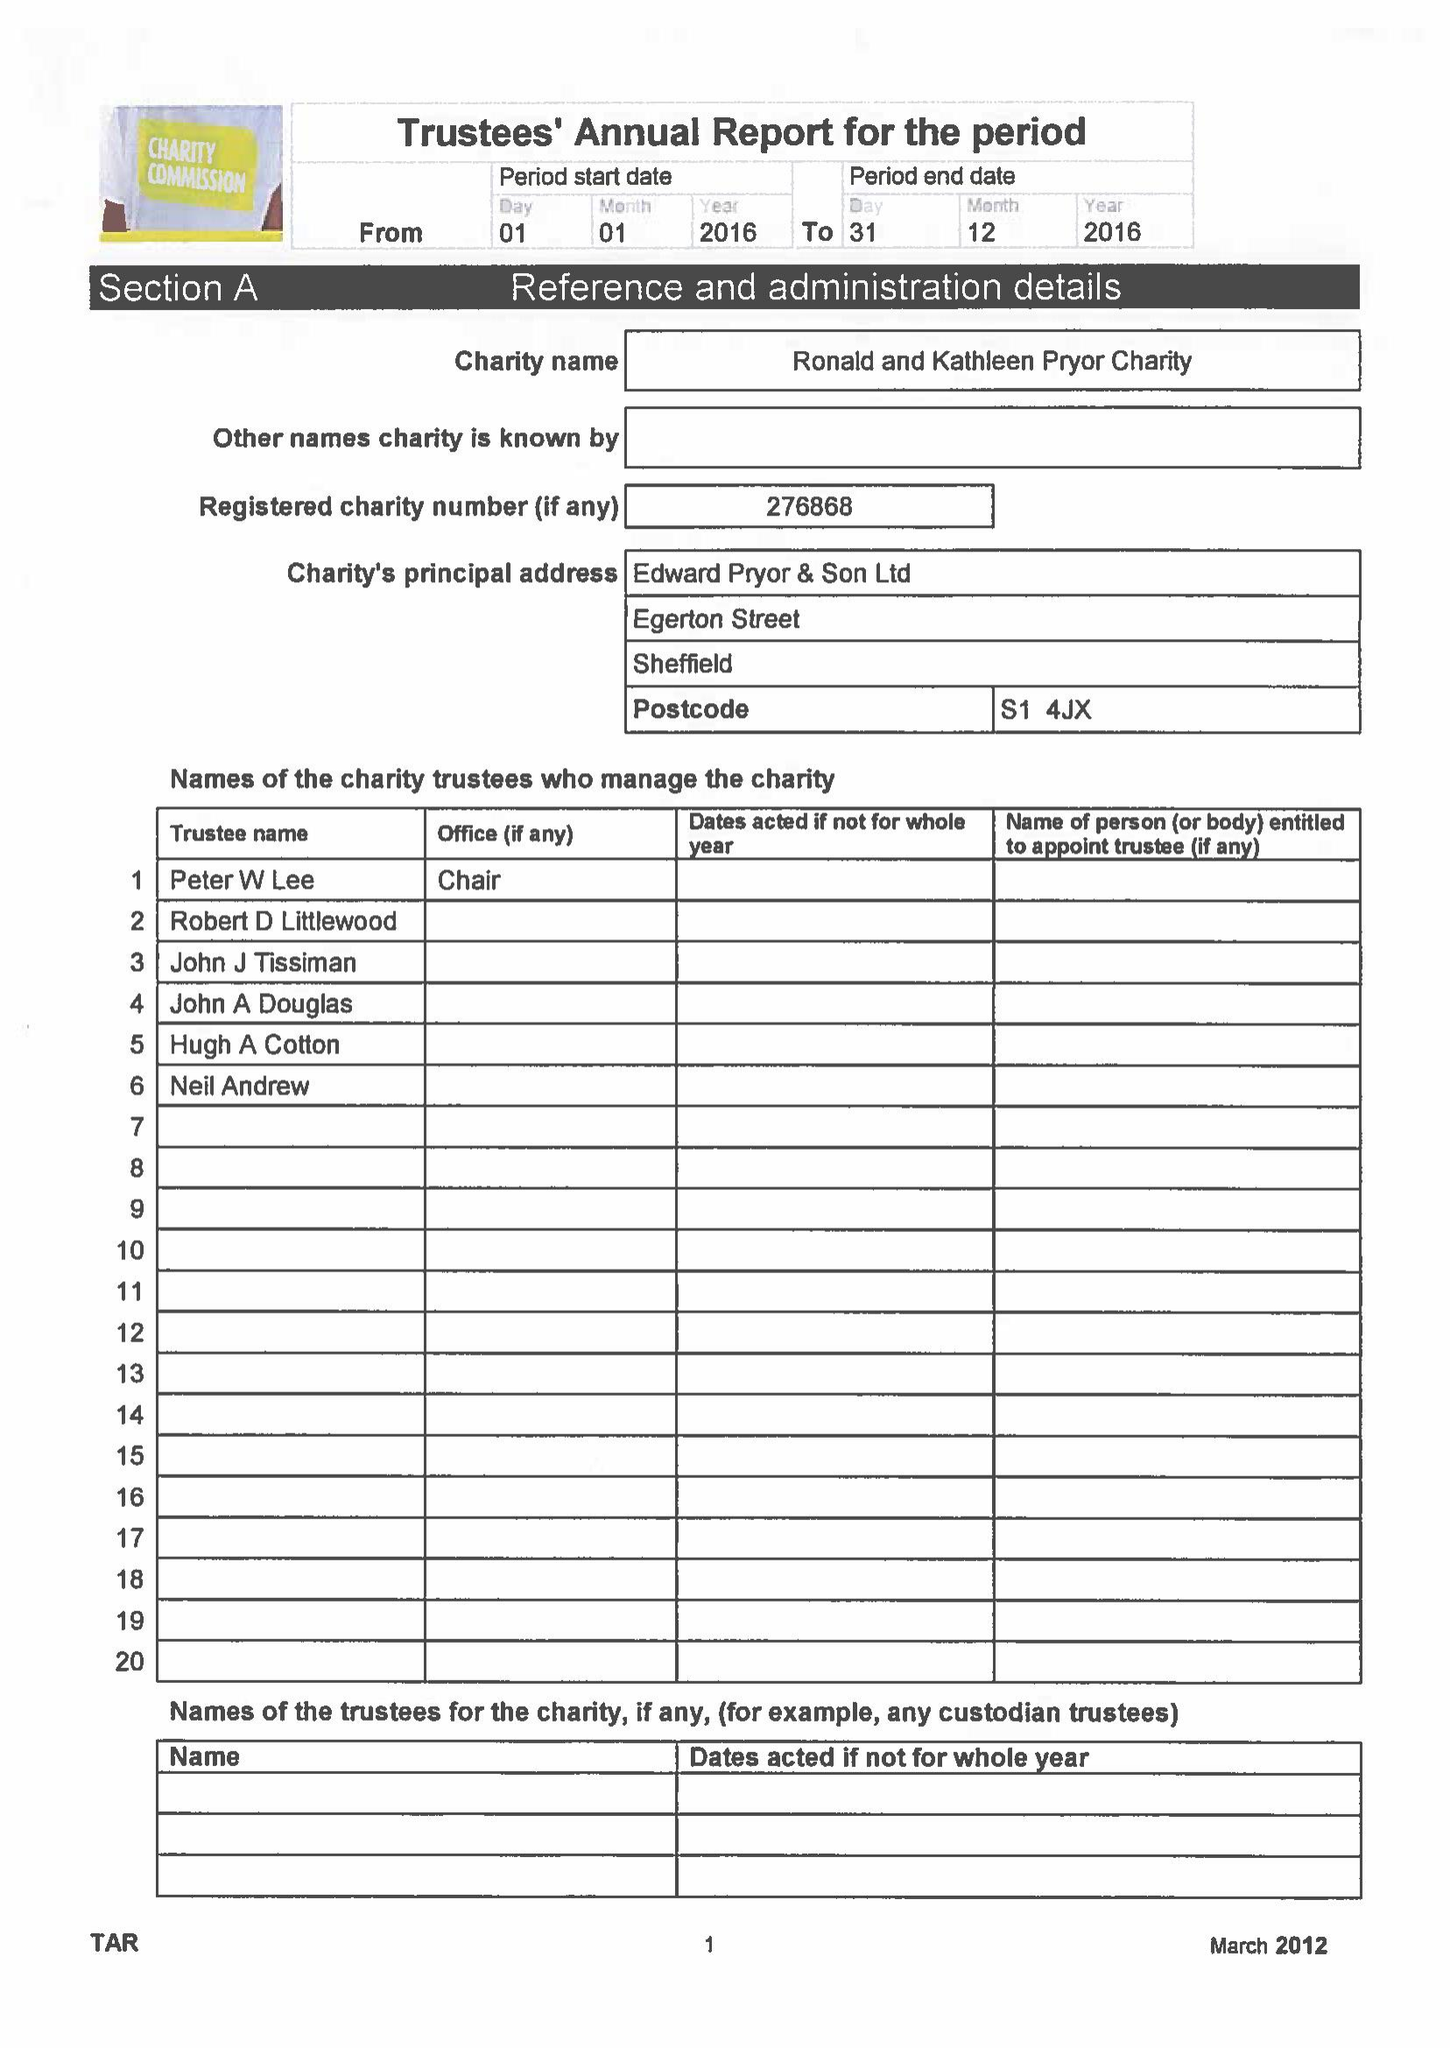What is the value for the charity_number?
Answer the question using a single word or phrase. 276868 